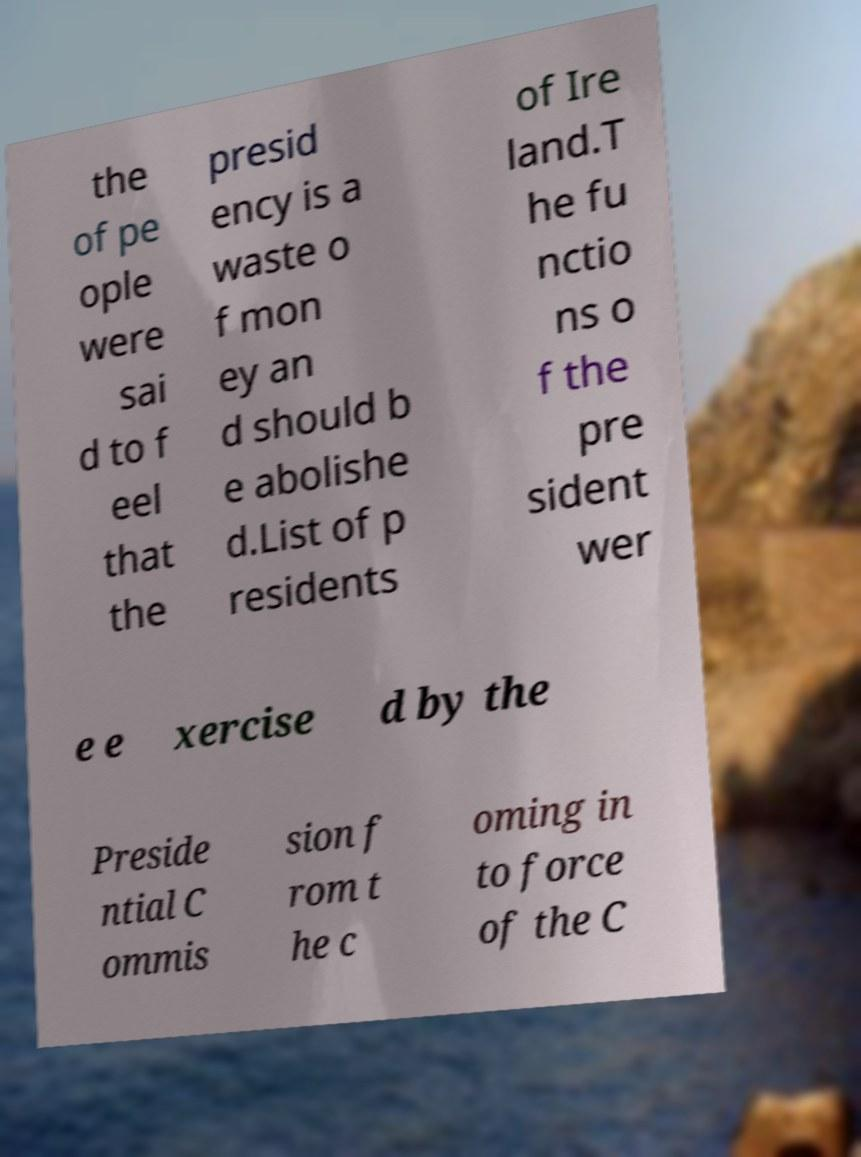Please read and relay the text visible in this image. What does it say? the of pe ople were sai d to f eel that the presid ency is a waste o f mon ey an d should b e abolishe d.List of p residents of Ire land.T he fu nctio ns o f the pre sident wer e e xercise d by the Preside ntial C ommis sion f rom t he c oming in to force of the C 